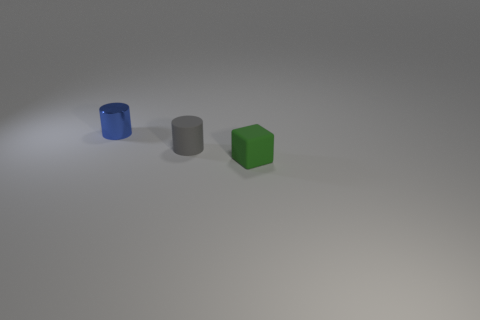Add 1 gray rubber things. How many objects exist? 4 Subtract 1 cubes. How many cubes are left? 0 Subtract all gray cylinders. How many cylinders are left? 1 Add 2 gray matte cylinders. How many gray matte cylinders are left? 3 Add 1 balls. How many balls exist? 1 Subtract 0 blue balls. How many objects are left? 3 Subtract all cylinders. How many objects are left? 1 Subtract all gray cylinders. Subtract all red blocks. How many cylinders are left? 1 Subtract all cyan blocks. How many green cylinders are left? 0 Subtract all gray things. Subtract all gray cylinders. How many objects are left? 1 